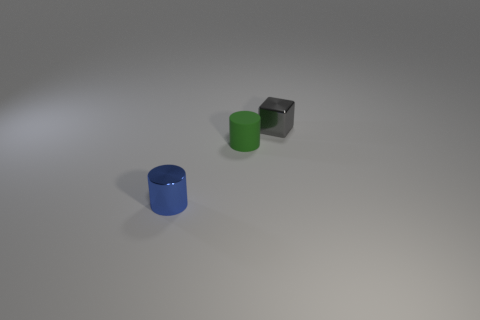What is the material of the small cylinder that is behind the tiny blue metal cylinder?
Offer a terse response. Rubber. There is a thing that is in front of the small green object; is its shape the same as the green rubber thing?
Keep it short and to the point. Yes. Are there any blue things of the same size as the green thing?
Your response must be concise. Yes. Is the shape of the small blue thing the same as the tiny green thing on the right side of the blue cylinder?
Provide a short and direct response. Yes. Are there fewer green rubber objects behind the tiny green matte cylinder than large purple shiny things?
Keep it short and to the point. No. Is the shape of the blue metallic object the same as the small green matte thing?
Give a very brief answer. Yes. Are there fewer shiny cylinders than large brown shiny cylinders?
Keep it short and to the point. No. What number of big objects are either metallic cubes or matte cylinders?
Keep it short and to the point. 0. How many tiny metal things are both to the right of the small rubber thing and on the left side of the green cylinder?
Offer a terse response. 0. Is the number of small gray blocks greater than the number of shiny objects?
Your response must be concise. No. 